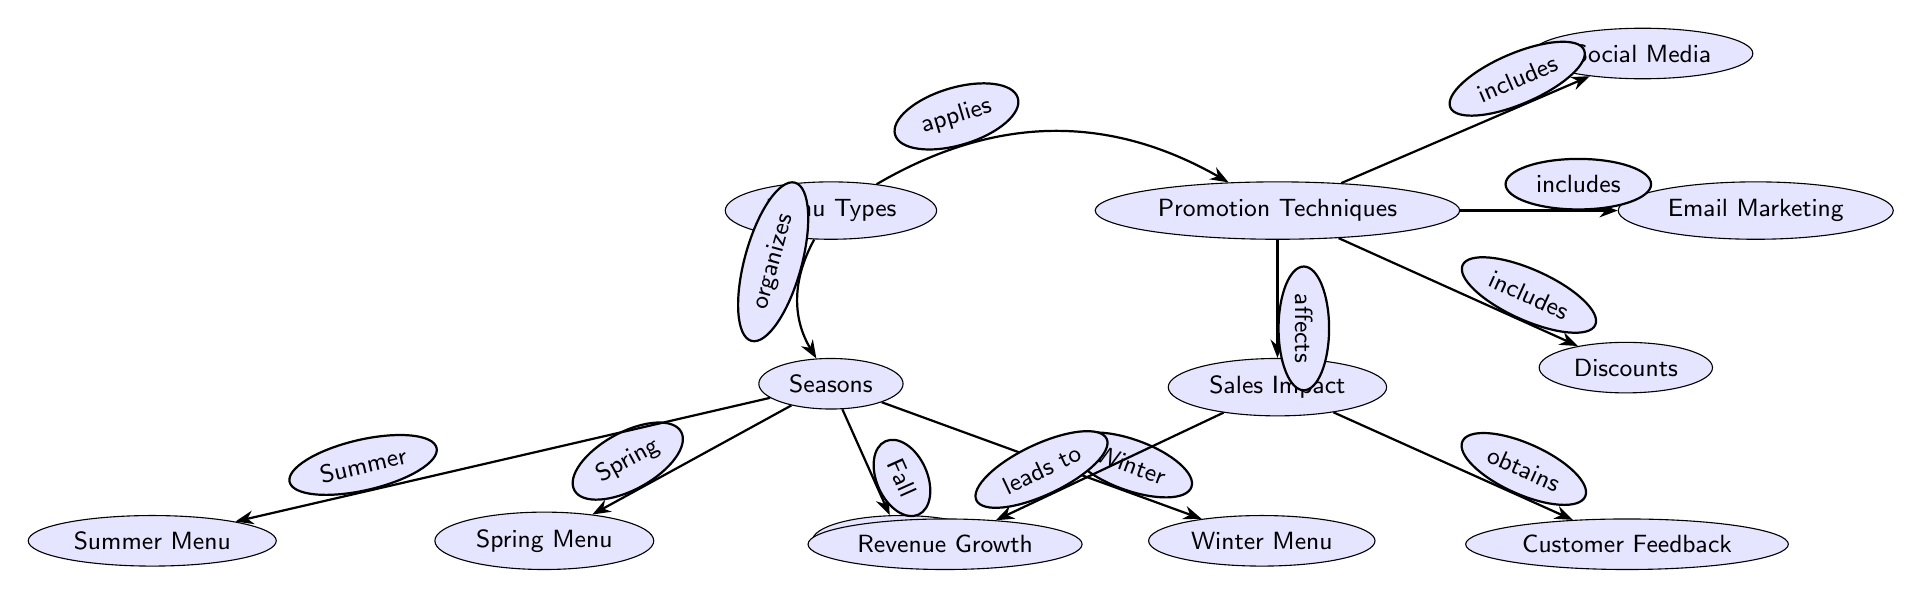What are the types of menus mentioned? The diagram lists four distinct menu types: Spring Menu, Summer Menu, Fall Menu, and Winter Menu, all categorized under the Menus Types node.
Answer: Spring Menu, Summer Menu, Fall Menu, Winter Menu How many promotion techniques are included? According to the Promotion Techniques node, there are three techniques listed: Social Media, Email Marketing, and Discounts.
Answer: 3 What does the Promotion Techniques node affect? The edge from Promotion Techniques to Sales Impact indicates that the promotion techniques affect the sales impact of the seasonal menu promotions.
Answer: Sales Impact Which menu type is associated with the season “Spring”? The diagram shows a direct connection from the Seasons node to the Spring Menu node, indicating that Spring Menu is specifically categorized under the Spring season.
Answer: Spring Menu What is the resulting effect of Sales Impact? The Sales Impact node leads to two outcomes: Revenue Growth and Customer Feedback, meaning that the impact on sales eventually results in these two effects.
Answer: Revenue Growth, Customer Feedback Describe the relationship between Menu Types and Promotion Techniques. The edge labeled "applies" indicates that the types of menus influence or use the promotion techniques, linking the Menu Types and Promotion Techniques nodes directly.
Answer: Applies What type of feedback can be obtained from the sales impact? The Sales Impact node includes a direct connection to the Customer Feedback node which indicates that customer feedback is gathered from the implications of sales impact.
Answer: Customer Feedback Which technique is included under Promotion Techniques? The edge labeled "includes" connects Promotion Techniques to various techniques like Social Media, Email Marketing, and Discounts, specifying that these are the techniques included.
Answer: Social Media, Email Marketing, Discounts What leads to revenue growth as per the diagram? Following the logic flow in the diagram, the direct connection from Sales Impact to Revenue Growth means that Sales Impact is what leads to revenue growth.
Answer: Sales Impact 